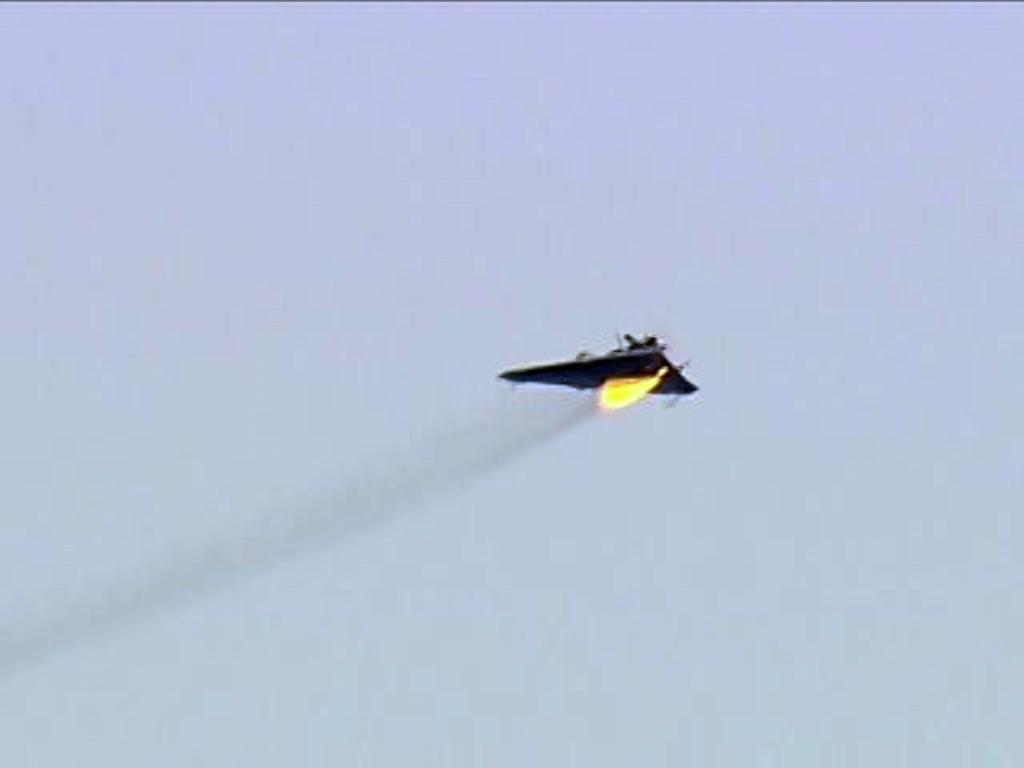Please provide a concise description of this image. In this image in the center there is an aircraft, and in the background there is sky. 